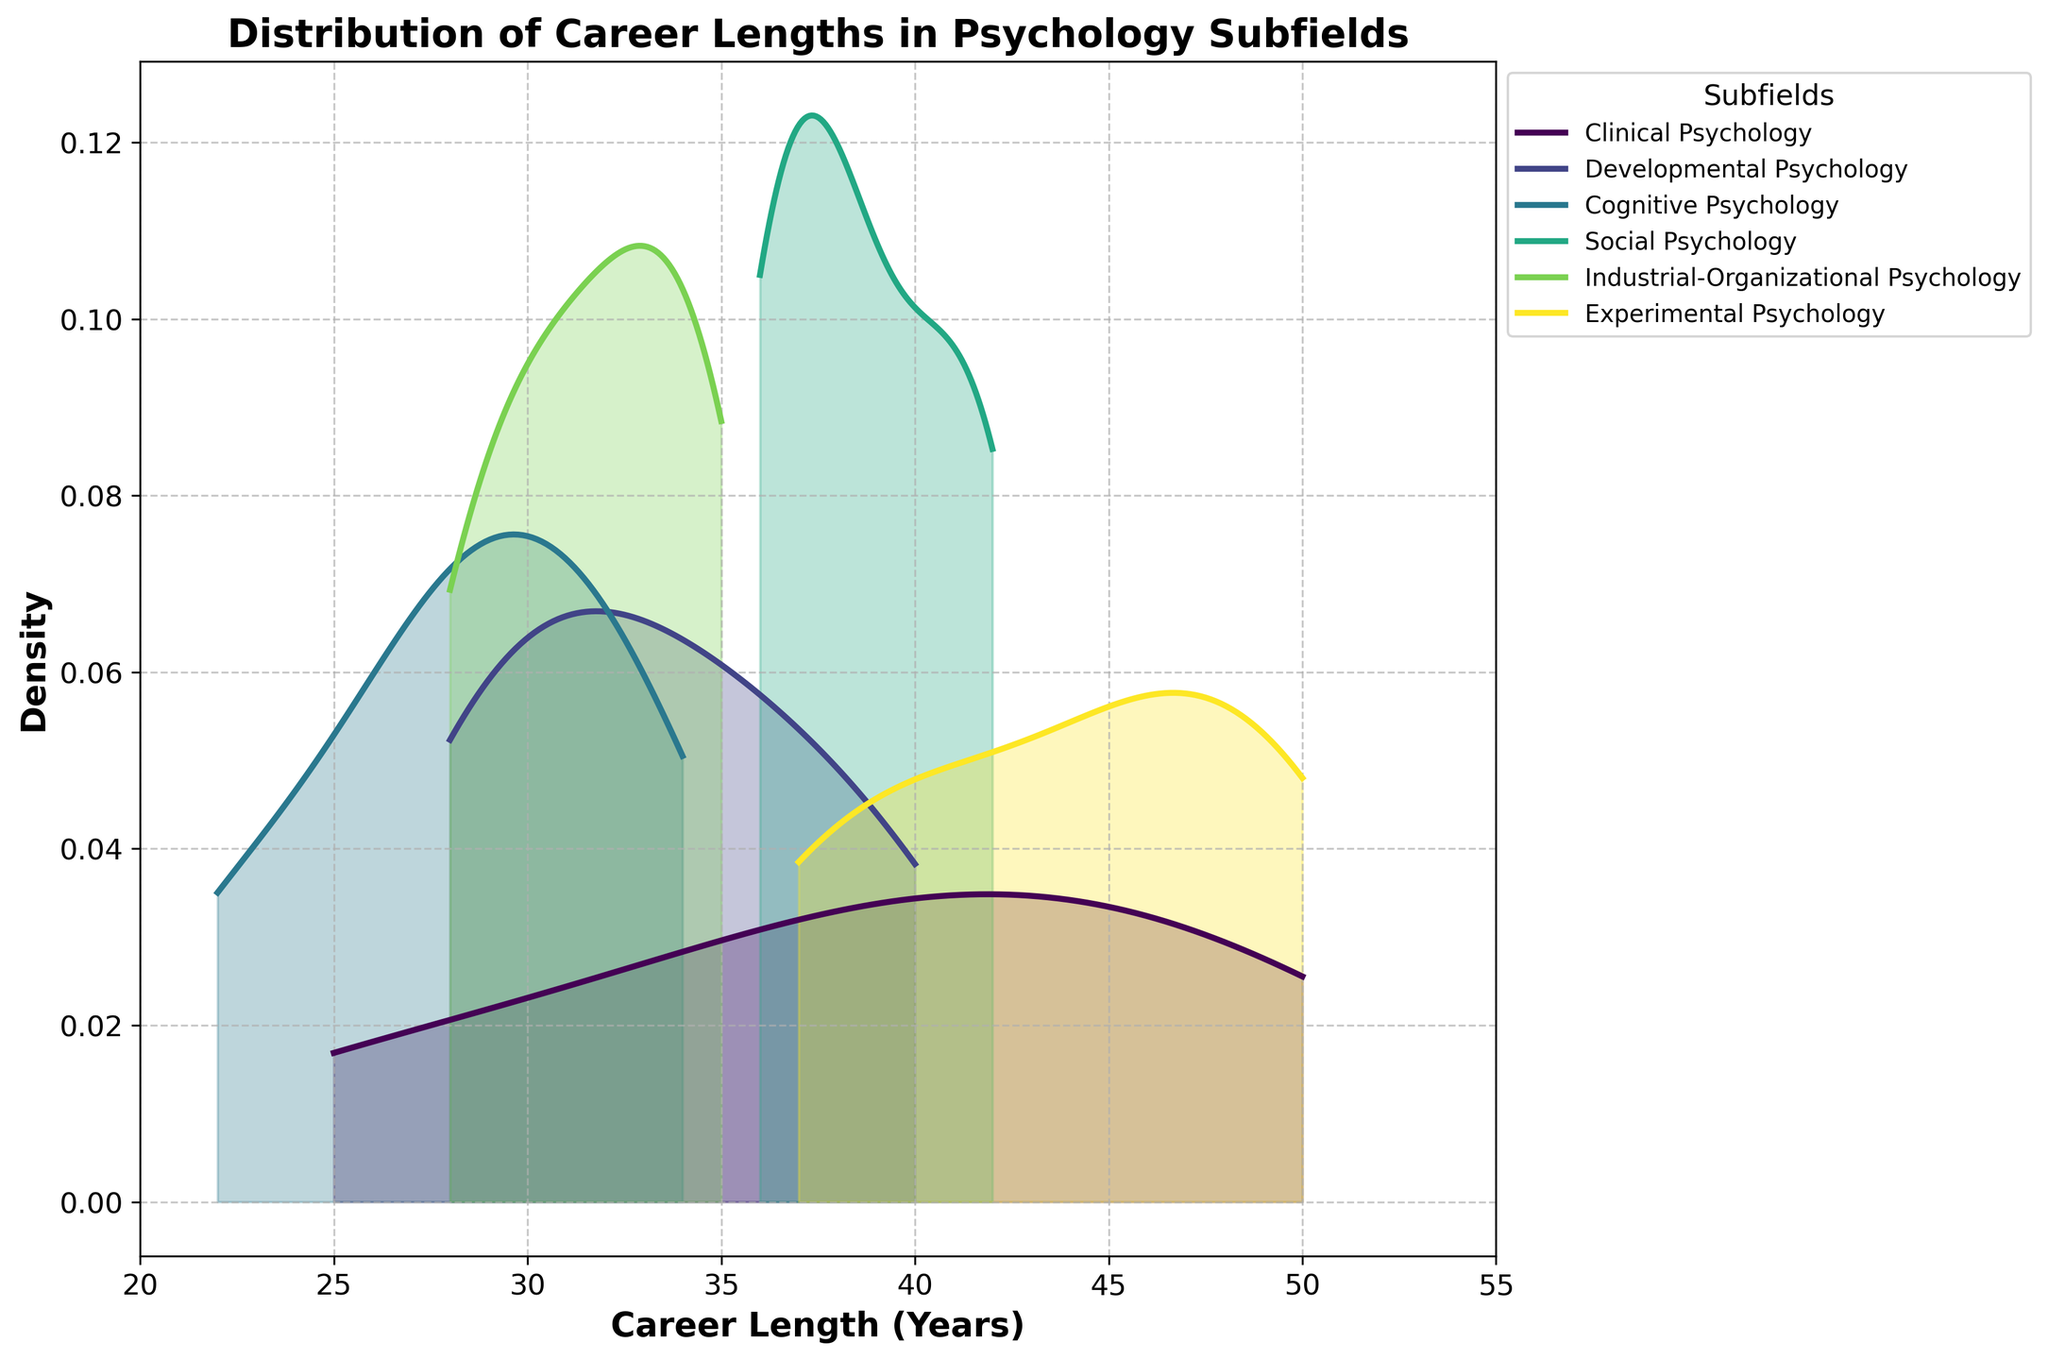What are the subfields displayed in the figure? The figure shows density plots for different subfields in psychology. By looking at the legend, we can identify each subfield represented by different colors.
Answer: Clinical Psychology, Developmental Psychology, Cognitive Psychology, Social Psychology, Industrial-Organizational Psychology, Experimental Psychology How many subfields are there in total? We can count the number of unique colors/lines in the legend of the plot, which correspond to the subfields.
Answer: 6 Which subfield has the longest career lengths represented in the plot? We need to identify the density plot that extends the furthest to the right on the x-axis. Here, Experimental Psychology has density extending up to 50 years, which is the longest compared to others.
Answer: Experimental Psychology What is the x-axis label? The x-axis label is given at the bottom of the plot.
Answer: Career Length (Years) Which subfield has the highest peak in density? By observing the height of the peaks in the density plots, we can determine which one is the tallest.
Answer: Social Psychology What is the range of career lengths displayed in the plot? We can determine the range by identifying the minimum and maximum values on the x-axis.
Answer: 20 to 55 years Between Clinical Psychology and Developmental Psychology, which has a greater spread in career lengths? We compare the density plots of Clinical Psychology and Developmental Psychology. Clinical Psychology has data spanning from around 25 to 50 years, while Developmental Psychology spans from 28 to 40 years.
Answer: Clinical Psychology Which subfield has a career length density that most closely matches Experimental Psychology? We need to look for a density plot that has a similar shape and range as Experimental Psychology's density plot. Social Psychology has a similar peak and range.
Answer: Social Psychology Is there any subfield whose density plot shows career lengths below 25 years? By examining the plots, the subfield density that starts below 25 years will be identified. Cognitive Psychology shows densities starting slightly below 25 years.
Answer: Cognitive Psychology What can you infer about the career lengths of experimental psychologists from their density plot? The density plot for Experimental Psychology shows a wide range with high density in the upper range (around 45-50 years), indicating that experimental psychologists often have long career lengths.
Answer: Long career lengths 